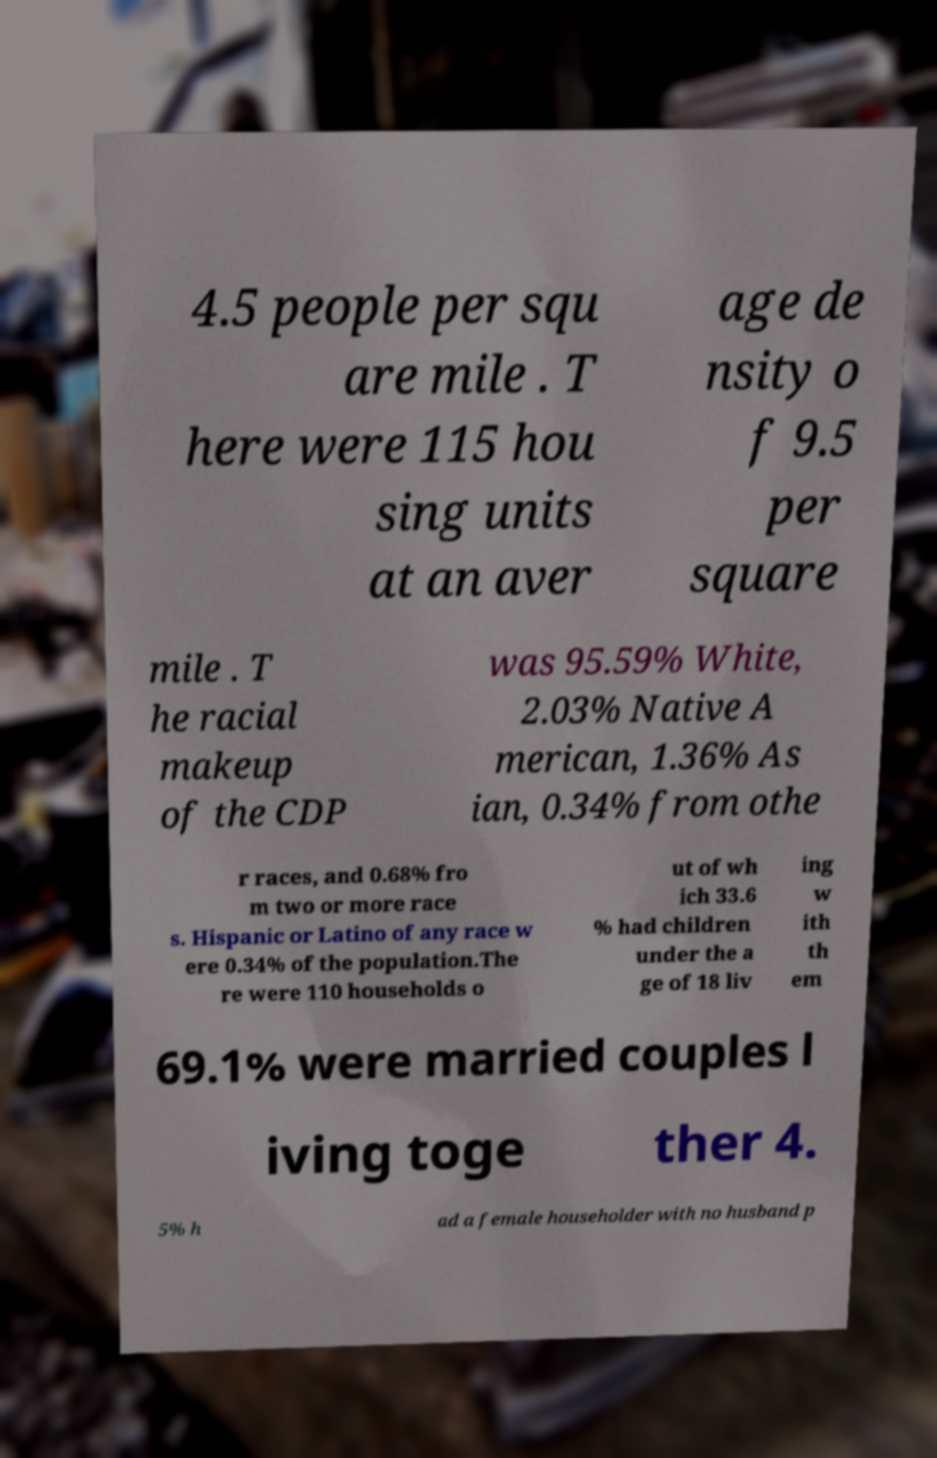For documentation purposes, I need the text within this image transcribed. Could you provide that? 4.5 people per squ are mile . T here were 115 hou sing units at an aver age de nsity o f 9.5 per square mile . T he racial makeup of the CDP was 95.59% White, 2.03% Native A merican, 1.36% As ian, 0.34% from othe r races, and 0.68% fro m two or more race s. Hispanic or Latino of any race w ere 0.34% of the population.The re were 110 households o ut of wh ich 33.6 % had children under the a ge of 18 liv ing w ith th em 69.1% were married couples l iving toge ther 4. 5% h ad a female householder with no husband p 